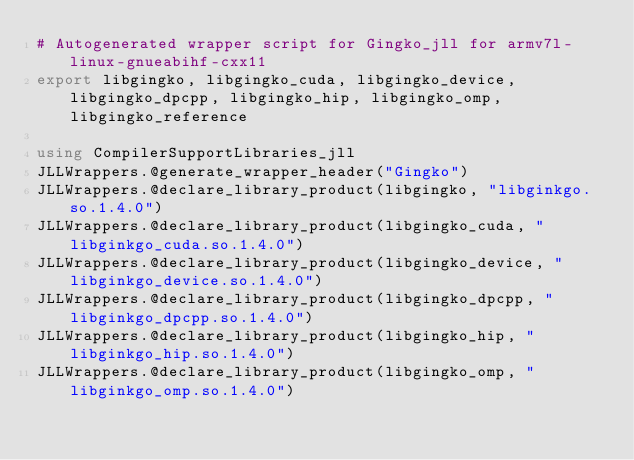Convert code to text. <code><loc_0><loc_0><loc_500><loc_500><_Julia_># Autogenerated wrapper script for Gingko_jll for armv7l-linux-gnueabihf-cxx11
export libgingko, libgingko_cuda, libgingko_device, libgingko_dpcpp, libgingko_hip, libgingko_omp, libgingko_reference

using CompilerSupportLibraries_jll
JLLWrappers.@generate_wrapper_header("Gingko")
JLLWrappers.@declare_library_product(libgingko, "libginkgo.so.1.4.0")
JLLWrappers.@declare_library_product(libgingko_cuda, "libginkgo_cuda.so.1.4.0")
JLLWrappers.@declare_library_product(libgingko_device, "libginkgo_device.so.1.4.0")
JLLWrappers.@declare_library_product(libgingko_dpcpp, "libginkgo_dpcpp.so.1.4.0")
JLLWrappers.@declare_library_product(libgingko_hip, "libginkgo_hip.so.1.4.0")
JLLWrappers.@declare_library_product(libgingko_omp, "libginkgo_omp.so.1.4.0")</code> 